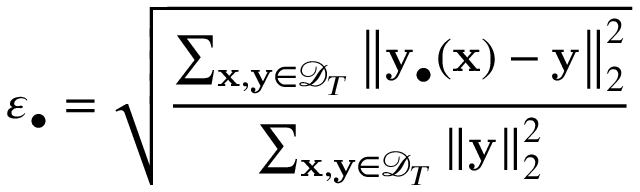Convert formula to latex. <formula><loc_0><loc_0><loc_500><loc_500>\varepsilon _ { \bullet } = \sqrt { \frac { \sum _ { x , y \in \mathcal { D } _ { T } } { \left \| y _ { \bullet } ( x ) - y \right \| _ { 2 } ^ { 2 } } } { \sum _ { x , y \in \mathcal { D } _ { T } } { \left \| y \right \| _ { 2 } ^ { 2 } } } }</formula> 